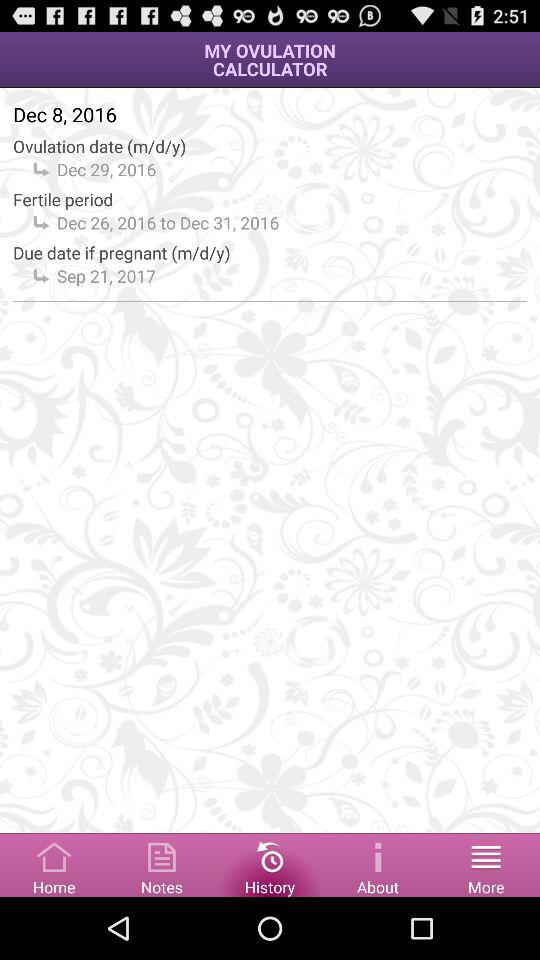What is today's date? Today's date is December 8, 2016. 